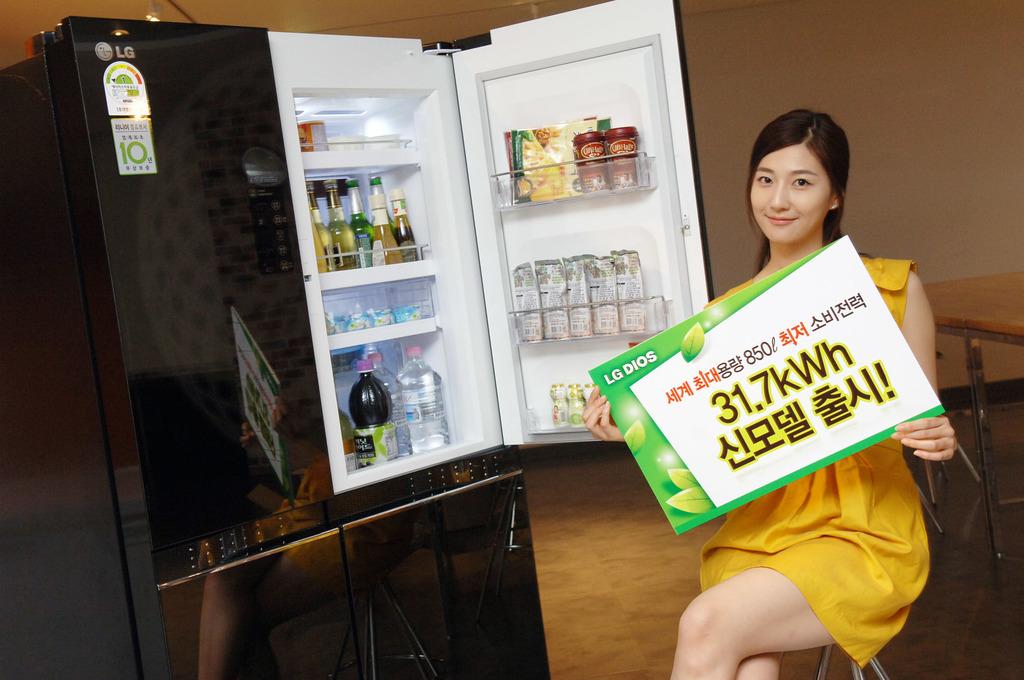How many kwh?
Give a very brief answer. 31.7. What number preceeds kwh?
Offer a very short reply. 31.7. 